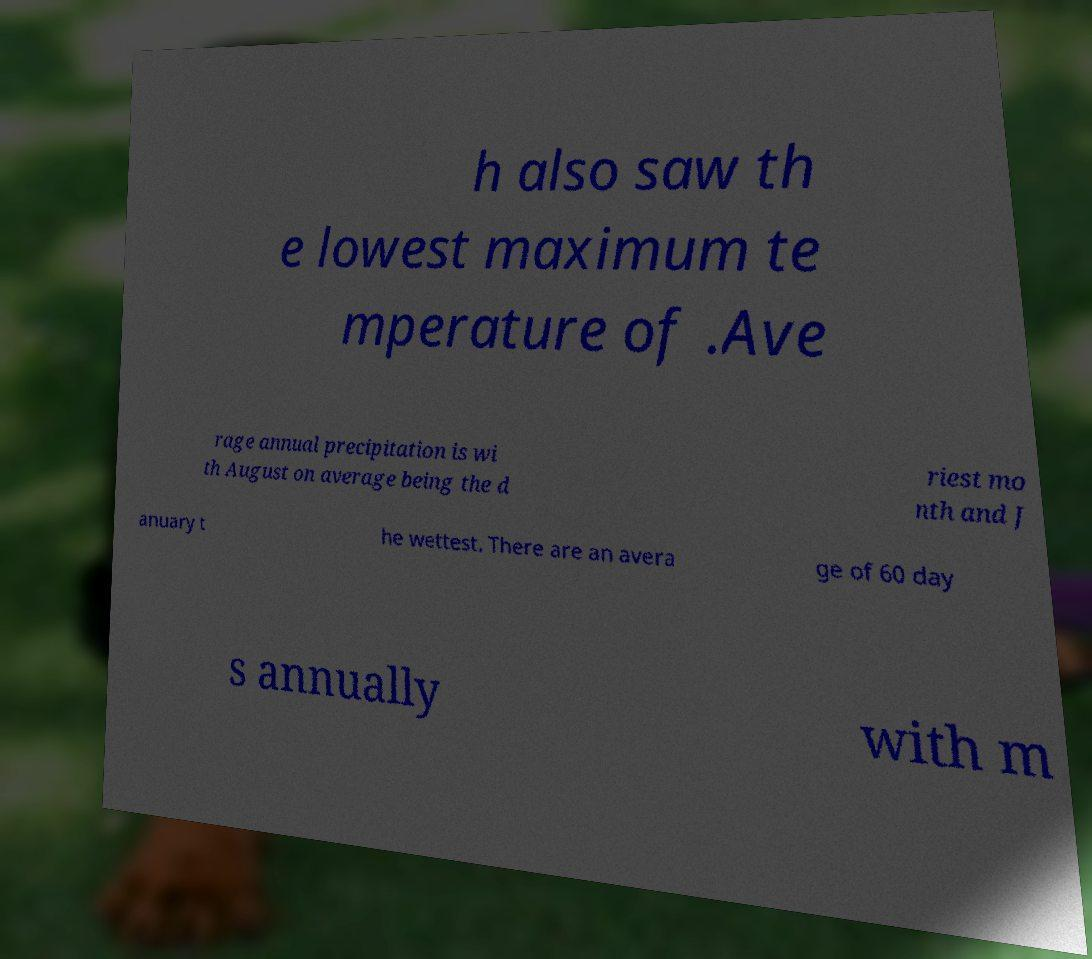There's text embedded in this image that I need extracted. Can you transcribe it verbatim? h also saw th e lowest maximum te mperature of .Ave rage annual precipitation is wi th August on average being the d riest mo nth and J anuary t he wettest. There are an avera ge of 60 day s annually with m 